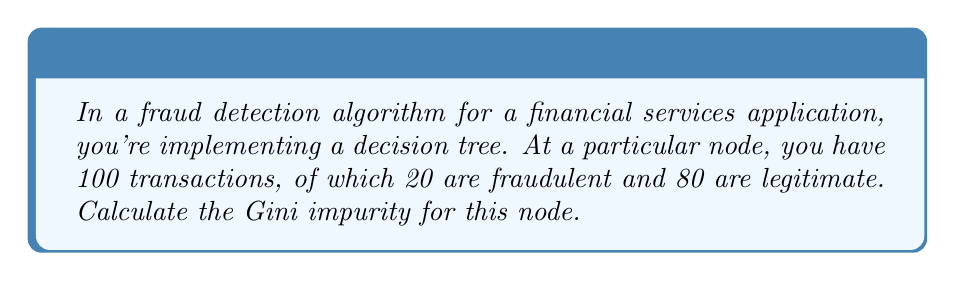Can you solve this math problem? To solve this problem, we'll follow these steps:

1. Understand Gini impurity:
   Gini impurity is a measure of how often a randomly chosen element from the set would be incorrectly labeled if it were randomly labeled according to the distribution of labels in the subset.

2. Recall the formula for Gini impurity:
   $$G = 1 - \sum_{i=1}^{n} p_i^2$$
   where $p_i$ is the probability of an item being classified for a particular class.

3. Identify the classes and their probabilities:
   - Fraudulent transactions: 20 out of 100
   - Legitimate transactions: 80 out of 100

4. Calculate the probabilities:
   - $p_{\text{fraudulent}} = \frac{20}{100} = 0.2$
   - $p_{\text{legitimate}} = \frac{80}{100} = 0.8$

5. Apply the Gini impurity formula:
   $$\begin{align*}
   G &= 1 - (p_{\text{fraudulent}}^2 + p_{\text{legitimate}}^2) \\
   &= 1 - (0.2^2 + 0.8^2) \\
   &= 1 - (0.04 + 0.64) \\
   &= 1 - 0.68 \\
   &= 0.32
   \end{align*}$$

The Gini impurity for this node is 0.32.
Answer: 0.32 